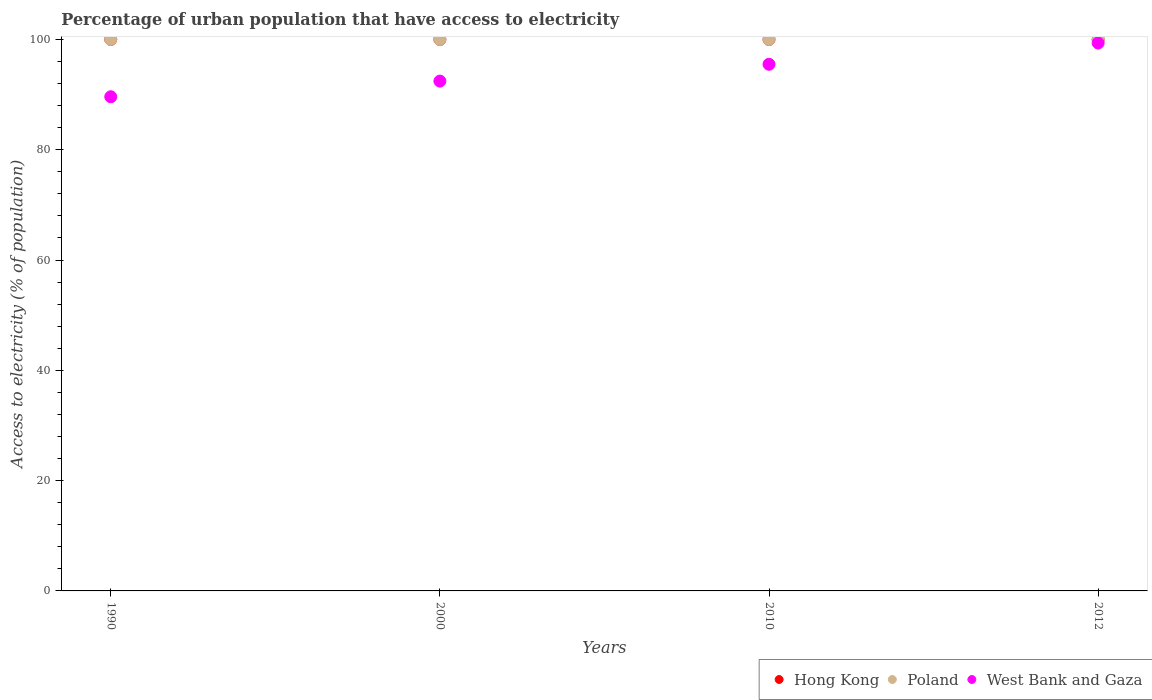How many different coloured dotlines are there?
Your answer should be compact. 3. Is the number of dotlines equal to the number of legend labels?
Your response must be concise. Yes. What is the percentage of urban population that have access to electricity in Hong Kong in 2010?
Keep it short and to the point. 100. Across all years, what is the maximum percentage of urban population that have access to electricity in Poland?
Keep it short and to the point. 100. Across all years, what is the minimum percentage of urban population that have access to electricity in West Bank and Gaza?
Your answer should be very brief. 89.61. In which year was the percentage of urban population that have access to electricity in Hong Kong maximum?
Your response must be concise. 1990. In which year was the percentage of urban population that have access to electricity in Hong Kong minimum?
Offer a very short reply. 1990. What is the total percentage of urban population that have access to electricity in Poland in the graph?
Offer a very short reply. 400. What is the difference between the percentage of urban population that have access to electricity in Hong Kong in 1990 and the percentage of urban population that have access to electricity in West Bank and Gaza in 2012?
Provide a succinct answer. 0.65. In the year 2010, what is the difference between the percentage of urban population that have access to electricity in Hong Kong and percentage of urban population that have access to electricity in West Bank and Gaza?
Provide a short and direct response. 4.5. In how many years, is the percentage of urban population that have access to electricity in Hong Kong greater than 92 %?
Keep it short and to the point. 4. What is the ratio of the percentage of urban population that have access to electricity in West Bank and Gaza in 2000 to that in 2012?
Your answer should be very brief. 0.93. Is the percentage of urban population that have access to electricity in Hong Kong in 1990 less than that in 2010?
Keep it short and to the point. No. What is the difference between the highest and the lowest percentage of urban population that have access to electricity in West Bank and Gaza?
Provide a short and direct response. 9.74. In how many years, is the percentage of urban population that have access to electricity in Poland greater than the average percentage of urban population that have access to electricity in Poland taken over all years?
Make the answer very short. 0. Is it the case that in every year, the sum of the percentage of urban population that have access to electricity in West Bank and Gaza and percentage of urban population that have access to electricity in Hong Kong  is greater than the percentage of urban population that have access to electricity in Poland?
Provide a short and direct response. Yes. What is the difference between two consecutive major ticks on the Y-axis?
Give a very brief answer. 20. Does the graph contain any zero values?
Your answer should be compact. No. Does the graph contain grids?
Ensure brevity in your answer.  No. How are the legend labels stacked?
Offer a terse response. Horizontal. What is the title of the graph?
Provide a short and direct response. Percentage of urban population that have access to electricity. What is the label or title of the X-axis?
Provide a succinct answer. Years. What is the label or title of the Y-axis?
Provide a succinct answer. Access to electricity (% of population). What is the Access to electricity (% of population) in Poland in 1990?
Provide a succinct answer. 100. What is the Access to electricity (% of population) of West Bank and Gaza in 1990?
Provide a short and direct response. 89.61. What is the Access to electricity (% of population) of Hong Kong in 2000?
Your answer should be compact. 100. What is the Access to electricity (% of population) in Poland in 2000?
Ensure brevity in your answer.  100. What is the Access to electricity (% of population) in West Bank and Gaza in 2000?
Make the answer very short. 92.45. What is the Access to electricity (% of population) of Hong Kong in 2010?
Keep it short and to the point. 100. What is the Access to electricity (% of population) of West Bank and Gaza in 2010?
Offer a very short reply. 95.5. What is the Access to electricity (% of population) of Poland in 2012?
Give a very brief answer. 100. What is the Access to electricity (% of population) of West Bank and Gaza in 2012?
Provide a succinct answer. 99.35. Across all years, what is the maximum Access to electricity (% of population) in West Bank and Gaza?
Your answer should be very brief. 99.35. Across all years, what is the minimum Access to electricity (% of population) in Hong Kong?
Provide a succinct answer. 100. Across all years, what is the minimum Access to electricity (% of population) in Poland?
Make the answer very short. 100. Across all years, what is the minimum Access to electricity (% of population) in West Bank and Gaza?
Ensure brevity in your answer.  89.61. What is the total Access to electricity (% of population) of Hong Kong in the graph?
Your answer should be very brief. 400. What is the total Access to electricity (% of population) of West Bank and Gaza in the graph?
Make the answer very short. 376.9. What is the difference between the Access to electricity (% of population) in Hong Kong in 1990 and that in 2000?
Make the answer very short. 0. What is the difference between the Access to electricity (% of population) of West Bank and Gaza in 1990 and that in 2000?
Keep it short and to the point. -2.84. What is the difference between the Access to electricity (% of population) in Hong Kong in 1990 and that in 2010?
Your answer should be compact. 0. What is the difference between the Access to electricity (% of population) of Poland in 1990 and that in 2010?
Offer a terse response. 0. What is the difference between the Access to electricity (% of population) in West Bank and Gaza in 1990 and that in 2010?
Provide a succinct answer. -5.89. What is the difference between the Access to electricity (% of population) in Hong Kong in 1990 and that in 2012?
Offer a very short reply. 0. What is the difference between the Access to electricity (% of population) of West Bank and Gaza in 1990 and that in 2012?
Ensure brevity in your answer.  -9.74. What is the difference between the Access to electricity (% of population) in Hong Kong in 2000 and that in 2010?
Offer a terse response. 0. What is the difference between the Access to electricity (% of population) in West Bank and Gaza in 2000 and that in 2010?
Give a very brief answer. -3.05. What is the difference between the Access to electricity (% of population) in Hong Kong in 2000 and that in 2012?
Your response must be concise. 0. What is the difference between the Access to electricity (% of population) in Poland in 2000 and that in 2012?
Make the answer very short. 0. What is the difference between the Access to electricity (% of population) of West Bank and Gaza in 2000 and that in 2012?
Provide a succinct answer. -6.9. What is the difference between the Access to electricity (% of population) of Hong Kong in 2010 and that in 2012?
Offer a terse response. 0. What is the difference between the Access to electricity (% of population) of West Bank and Gaza in 2010 and that in 2012?
Your answer should be very brief. -3.85. What is the difference between the Access to electricity (% of population) in Hong Kong in 1990 and the Access to electricity (% of population) in West Bank and Gaza in 2000?
Provide a succinct answer. 7.55. What is the difference between the Access to electricity (% of population) in Poland in 1990 and the Access to electricity (% of population) in West Bank and Gaza in 2000?
Offer a very short reply. 7.55. What is the difference between the Access to electricity (% of population) in Hong Kong in 1990 and the Access to electricity (% of population) in West Bank and Gaza in 2010?
Your response must be concise. 4.5. What is the difference between the Access to electricity (% of population) of Poland in 1990 and the Access to electricity (% of population) of West Bank and Gaza in 2010?
Provide a succinct answer. 4.5. What is the difference between the Access to electricity (% of population) of Hong Kong in 1990 and the Access to electricity (% of population) of West Bank and Gaza in 2012?
Provide a succinct answer. 0.65. What is the difference between the Access to electricity (% of population) in Poland in 1990 and the Access to electricity (% of population) in West Bank and Gaza in 2012?
Provide a short and direct response. 0.65. What is the difference between the Access to electricity (% of population) in Hong Kong in 2000 and the Access to electricity (% of population) in Poland in 2010?
Provide a succinct answer. 0. What is the difference between the Access to electricity (% of population) of Hong Kong in 2000 and the Access to electricity (% of population) of West Bank and Gaza in 2010?
Provide a short and direct response. 4.5. What is the difference between the Access to electricity (% of population) of Poland in 2000 and the Access to electricity (% of population) of West Bank and Gaza in 2010?
Give a very brief answer. 4.5. What is the difference between the Access to electricity (% of population) of Hong Kong in 2000 and the Access to electricity (% of population) of Poland in 2012?
Ensure brevity in your answer.  0. What is the difference between the Access to electricity (% of population) in Hong Kong in 2000 and the Access to electricity (% of population) in West Bank and Gaza in 2012?
Your response must be concise. 0.65. What is the difference between the Access to electricity (% of population) of Poland in 2000 and the Access to electricity (% of population) of West Bank and Gaza in 2012?
Your answer should be compact. 0.65. What is the difference between the Access to electricity (% of population) in Hong Kong in 2010 and the Access to electricity (% of population) in Poland in 2012?
Keep it short and to the point. 0. What is the difference between the Access to electricity (% of population) of Hong Kong in 2010 and the Access to electricity (% of population) of West Bank and Gaza in 2012?
Your answer should be compact. 0.65. What is the difference between the Access to electricity (% of population) of Poland in 2010 and the Access to electricity (% of population) of West Bank and Gaza in 2012?
Make the answer very short. 0.65. What is the average Access to electricity (% of population) of West Bank and Gaza per year?
Offer a very short reply. 94.22. In the year 1990, what is the difference between the Access to electricity (% of population) in Hong Kong and Access to electricity (% of population) in Poland?
Make the answer very short. 0. In the year 1990, what is the difference between the Access to electricity (% of population) in Hong Kong and Access to electricity (% of population) in West Bank and Gaza?
Your response must be concise. 10.39. In the year 1990, what is the difference between the Access to electricity (% of population) of Poland and Access to electricity (% of population) of West Bank and Gaza?
Keep it short and to the point. 10.39. In the year 2000, what is the difference between the Access to electricity (% of population) in Hong Kong and Access to electricity (% of population) in West Bank and Gaza?
Your response must be concise. 7.55. In the year 2000, what is the difference between the Access to electricity (% of population) of Poland and Access to electricity (% of population) of West Bank and Gaza?
Ensure brevity in your answer.  7.55. In the year 2010, what is the difference between the Access to electricity (% of population) of Hong Kong and Access to electricity (% of population) of Poland?
Offer a very short reply. 0. In the year 2010, what is the difference between the Access to electricity (% of population) in Hong Kong and Access to electricity (% of population) in West Bank and Gaza?
Make the answer very short. 4.5. In the year 2010, what is the difference between the Access to electricity (% of population) of Poland and Access to electricity (% of population) of West Bank and Gaza?
Provide a short and direct response. 4.5. In the year 2012, what is the difference between the Access to electricity (% of population) of Hong Kong and Access to electricity (% of population) of Poland?
Keep it short and to the point. 0. In the year 2012, what is the difference between the Access to electricity (% of population) in Hong Kong and Access to electricity (% of population) in West Bank and Gaza?
Give a very brief answer. 0.65. In the year 2012, what is the difference between the Access to electricity (% of population) in Poland and Access to electricity (% of population) in West Bank and Gaza?
Give a very brief answer. 0.65. What is the ratio of the Access to electricity (% of population) in Hong Kong in 1990 to that in 2000?
Your answer should be compact. 1. What is the ratio of the Access to electricity (% of population) of West Bank and Gaza in 1990 to that in 2000?
Offer a very short reply. 0.97. What is the ratio of the Access to electricity (% of population) of Poland in 1990 to that in 2010?
Offer a terse response. 1. What is the ratio of the Access to electricity (% of population) of West Bank and Gaza in 1990 to that in 2010?
Make the answer very short. 0.94. What is the ratio of the Access to electricity (% of population) in Hong Kong in 1990 to that in 2012?
Keep it short and to the point. 1. What is the ratio of the Access to electricity (% of population) in West Bank and Gaza in 1990 to that in 2012?
Keep it short and to the point. 0.9. What is the ratio of the Access to electricity (% of population) of Hong Kong in 2000 to that in 2010?
Keep it short and to the point. 1. What is the ratio of the Access to electricity (% of population) in Poland in 2000 to that in 2010?
Make the answer very short. 1. What is the ratio of the Access to electricity (% of population) in West Bank and Gaza in 2000 to that in 2010?
Ensure brevity in your answer.  0.97. What is the ratio of the Access to electricity (% of population) in Hong Kong in 2000 to that in 2012?
Make the answer very short. 1. What is the ratio of the Access to electricity (% of population) in Poland in 2000 to that in 2012?
Your answer should be very brief. 1. What is the ratio of the Access to electricity (% of population) in West Bank and Gaza in 2000 to that in 2012?
Make the answer very short. 0.93. What is the ratio of the Access to electricity (% of population) in Hong Kong in 2010 to that in 2012?
Make the answer very short. 1. What is the ratio of the Access to electricity (% of population) of Poland in 2010 to that in 2012?
Your answer should be very brief. 1. What is the ratio of the Access to electricity (% of population) in West Bank and Gaza in 2010 to that in 2012?
Keep it short and to the point. 0.96. What is the difference between the highest and the second highest Access to electricity (% of population) of Hong Kong?
Ensure brevity in your answer.  0. What is the difference between the highest and the second highest Access to electricity (% of population) of Poland?
Your answer should be very brief. 0. What is the difference between the highest and the second highest Access to electricity (% of population) of West Bank and Gaza?
Ensure brevity in your answer.  3.85. What is the difference between the highest and the lowest Access to electricity (% of population) in Poland?
Give a very brief answer. 0. What is the difference between the highest and the lowest Access to electricity (% of population) of West Bank and Gaza?
Provide a succinct answer. 9.74. 